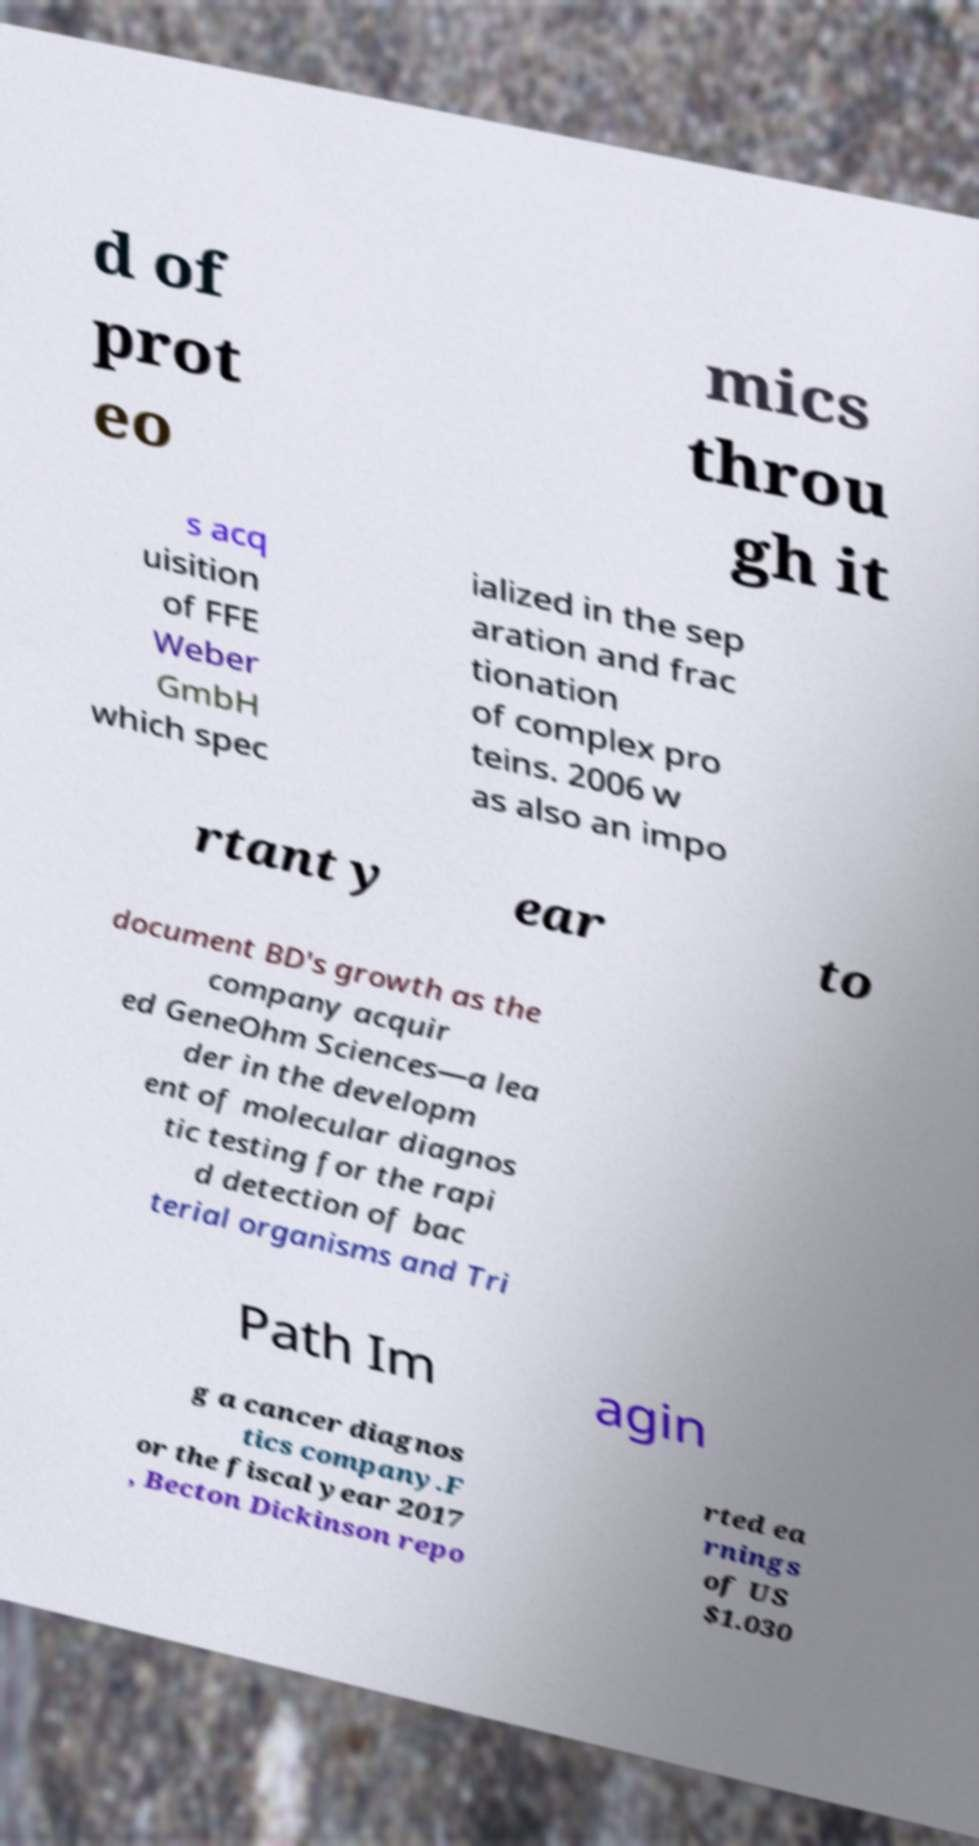Can you read and provide the text displayed in the image?This photo seems to have some interesting text. Can you extract and type it out for me? d of prot eo mics throu gh it s acq uisition of FFE Weber GmbH which spec ialized in the sep aration and frac tionation of complex pro teins. 2006 w as also an impo rtant y ear to document BD's growth as the company acquir ed GeneOhm Sciences—a lea der in the developm ent of molecular diagnos tic testing for the rapi d detection of bac terial organisms and Tri Path Im agin g a cancer diagnos tics company.F or the fiscal year 2017 , Becton Dickinson repo rted ea rnings of US $1.030 